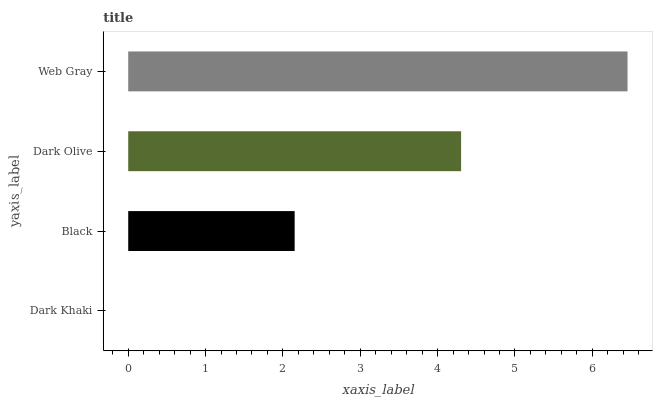Is Dark Khaki the minimum?
Answer yes or no. Yes. Is Web Gray the maximum?
Answer yes or no. Yes. Is Black the minimum?
Answer yes or no. No. Is Black the maximum?
Answer yes or no. No. Is Black greater than Dark Khaki?
Answer yes or no. Yes. Is Dark Khaki less than Black?
Answer yes or no. Yes. Is Dark Khaki greater than Black?
Answer yes or no. No. Is Black less than Dark Khaki?
Answer yes or no. No. Is Dark Olive the high median?
Answer yes or no. Yes. Is Black the low median?
Answer yes or no. Yes. Is Black the high median?
Answer yes or no. No. Is Web Gray the low median?
Answer yes or no. No. 